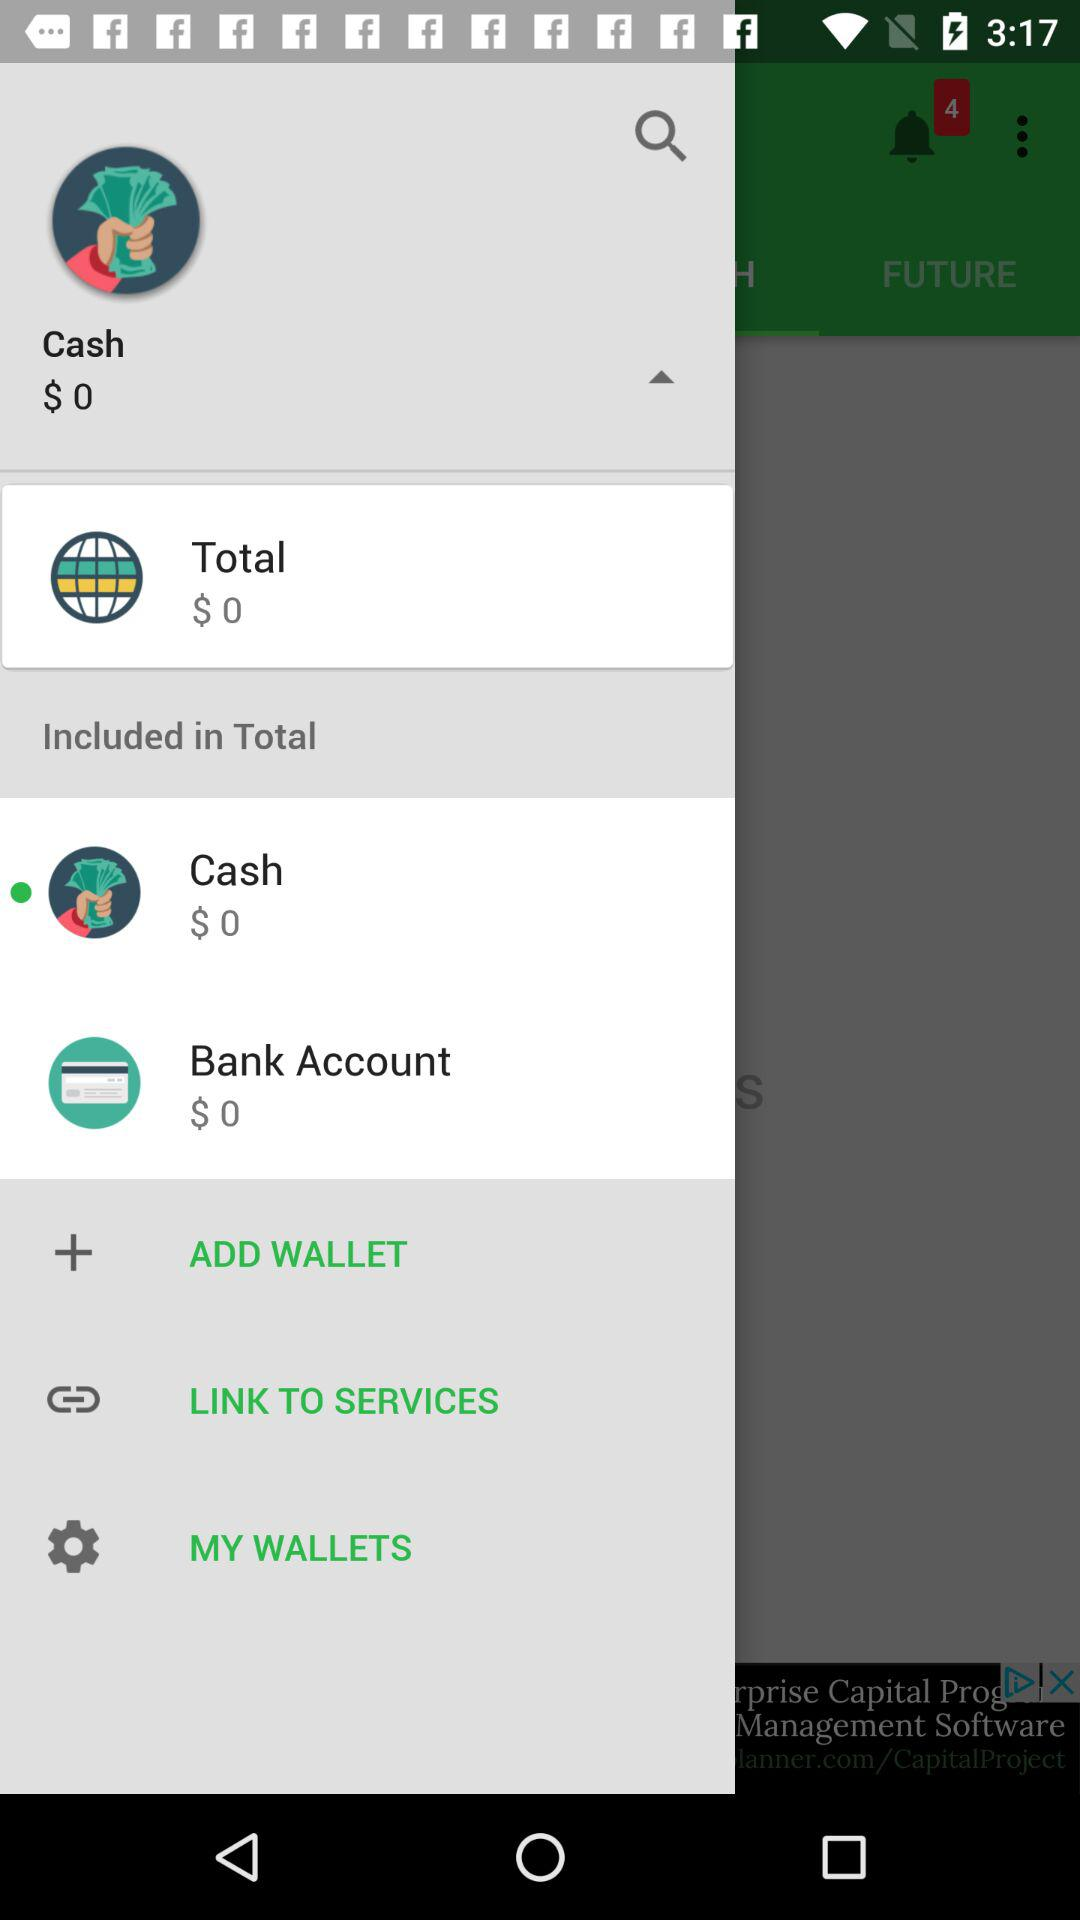What is the total amount? The total amount is $0. 